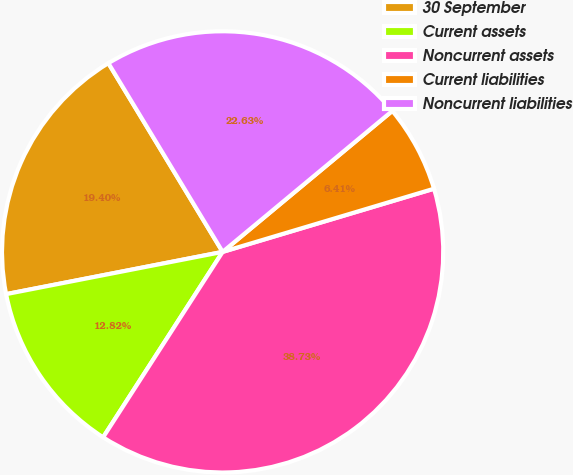<chart> <loc_0><loc_0><loc_500><loc_500><pie_chart><fcel>30 September<fcel>Current assets<fcel>Noncurrent assets<fcel>Current liabilities<fcel>Noncurrent liabilities<nl><fcel>19.4%<fcel>12.82%<fcel>38.73%<fcel>6.41%<fcel>22.63%<nl></chart> 